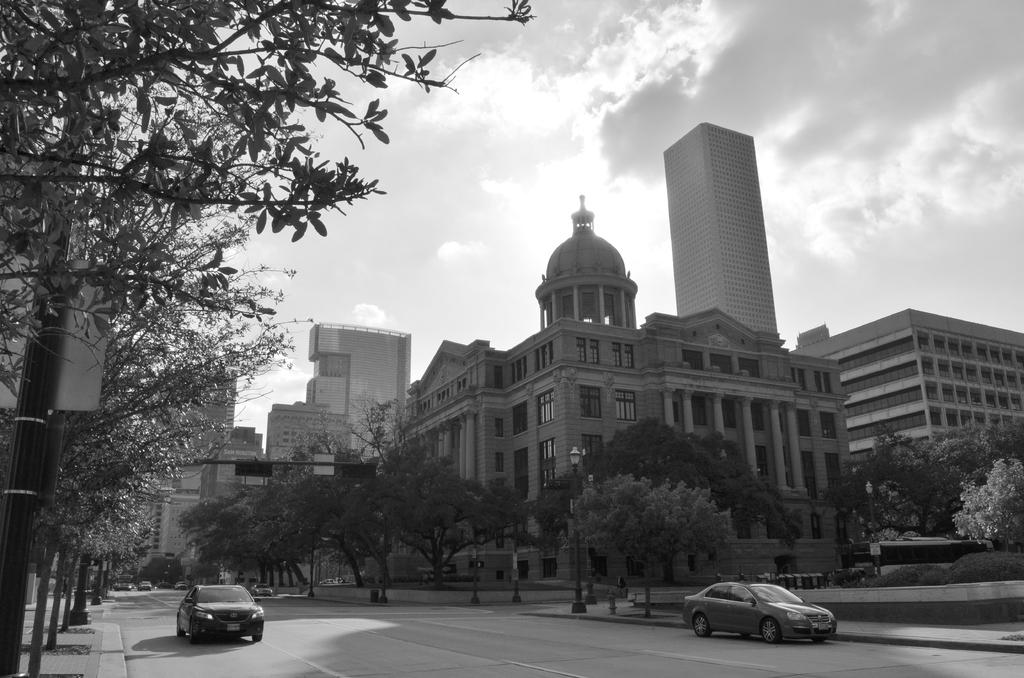What type of structures can be seen in the image? There are buildings in the image. What other natural elements are present in the image? There are trees in the image. What is used to regulate traffic in the image? There is a traffic signal light on a pole. What type of vehicles can be seen on the road in the image? There are cars on the road in the image. How would you describe the weather based on the image? The sky is cloudy in the image. What color is the hammer hanging from the tree in the image? There is no hammer present in the image. How many birds are perched on the traffic signal light in the image? There are no birds present in the image. 